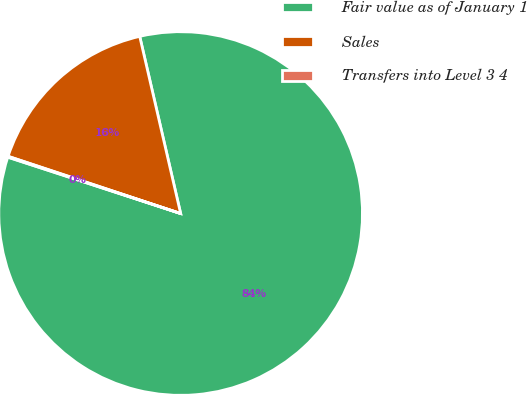Convert chart to OTSL. <chart><loc_0><loc_0><loc_500><loc_500><pie_chart><fcel>Fair value as of January 1<fcel>Sales<fcel>Transfers into Level 3 4<nl><fcel>83.63%<fcel>16.29%<fcel>0.08%<nl></chart> 